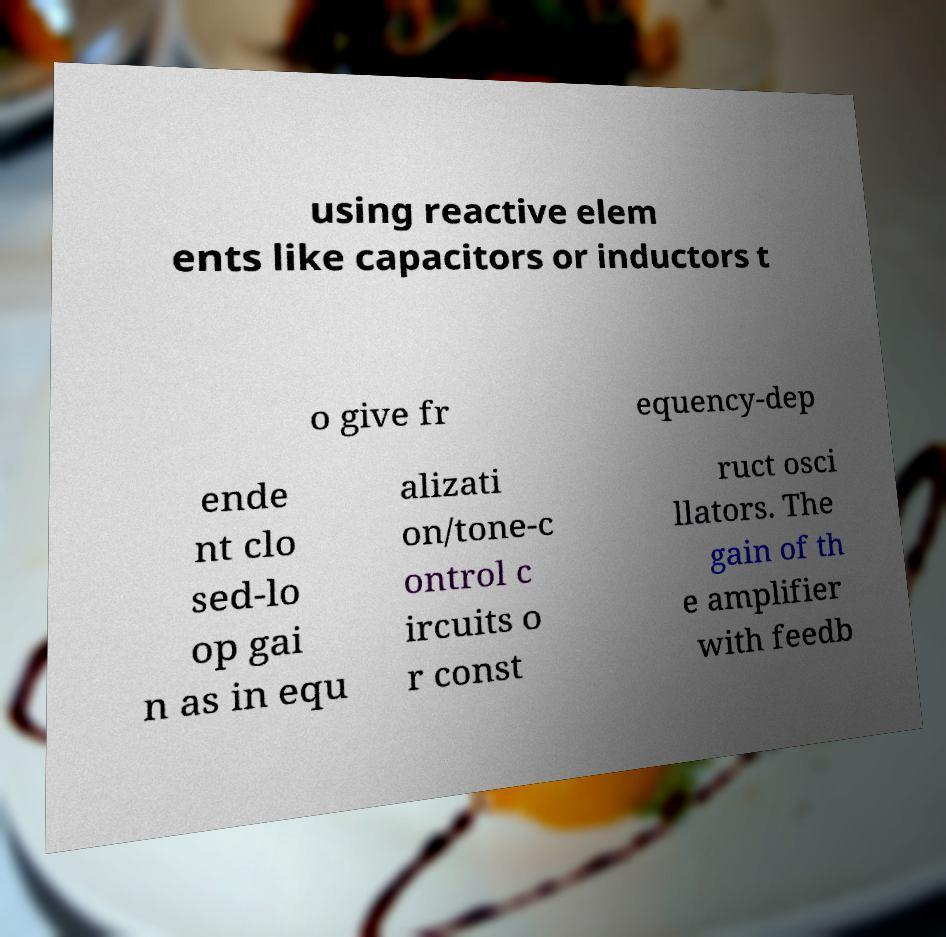Please identify and transcribe the text found in this image. using reactive elem ents like capacitors or inductors t o give fr equency-dep ende nt clo sed-lo op gai n as in equ alizati on/tone-c ontrol c ircuits o r const ruct osci llators. The gain of th e amplifier with feedb 